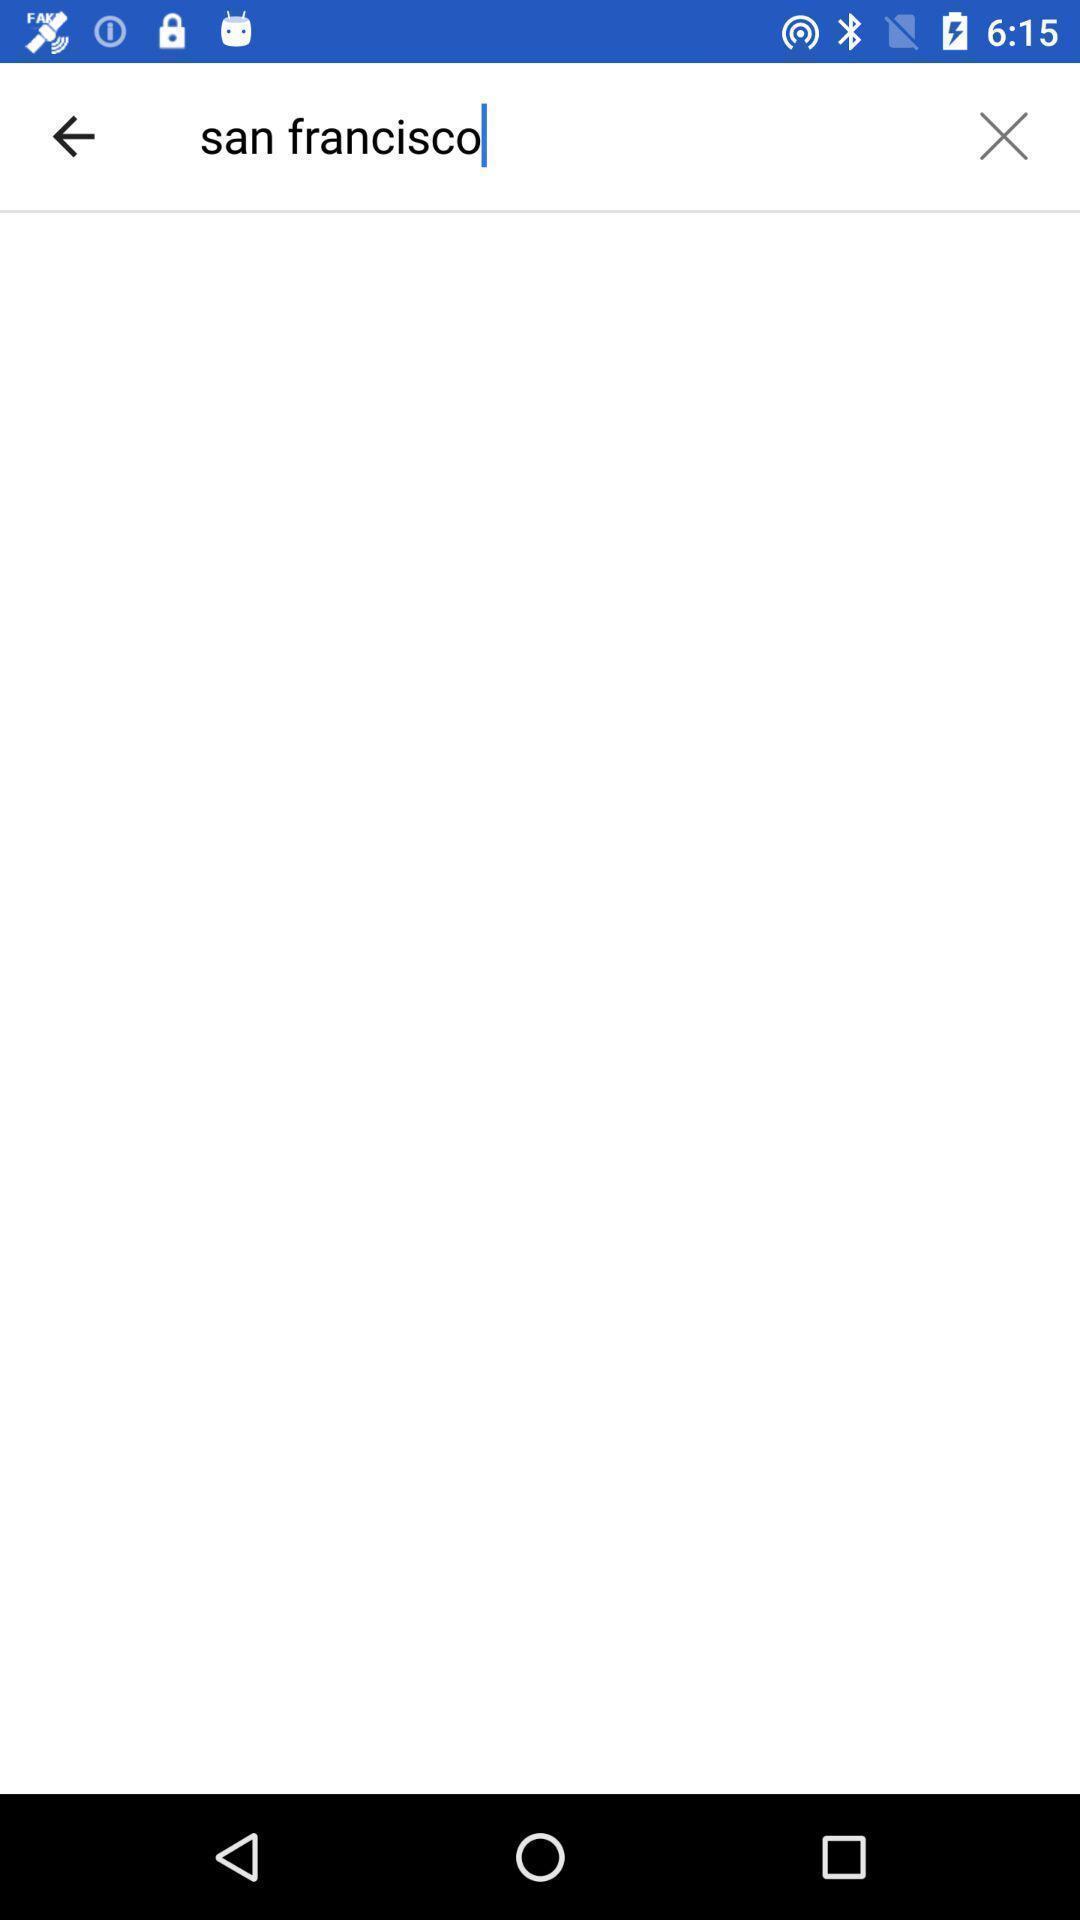Tell me what you see in this picture. Search bar to find locations. 